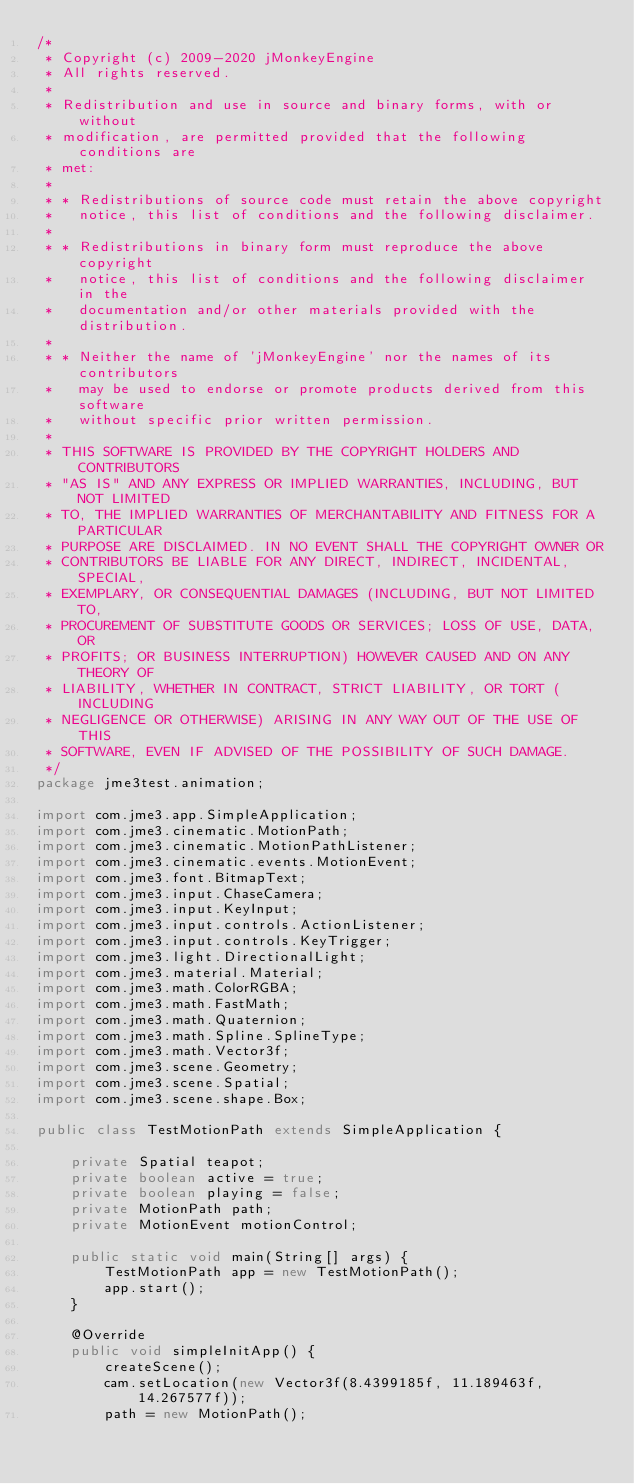Convert code to text. <code><loc_0><loc_0><loc_500><loc_500><_Java_>/*
 * Copyright (c) 2009-2020 jMonkeyEngine
 * All rights reserved.
 *
 * Redistribution and use in source and binary forms, with or without
 * modification, are permitted provided that the following conditions are
 * met:
 *
 * * Redistributions of source code must retain the above copyright
 *   notice, this list of conditions and the following disclaimer.
 *
 * * Redistributions in binary form must reproduce the above copyright
 *   notice, this list of conditions and the following disclaimer in the
 *   documentation and/or other materials provided with the distribution.
 *
 * * Neither the name of 'jMonkeyEngine' nor the names of its contributors
 *   may be used to endorse or promote products derived from this software
 *   without specific prior written permission.
 *
 * THIS SOFTWARE IS PROVIDED BY THE COPYRIGHT HOLDERS AND CONTRIBUTORS
 * "AS IS" AND ANY EXPRESS OR IMPLIED WARRANTIES, INCLUDING, BUT NOT LIMITED
 * TO, THE IMPLIED WARRANTIES OF MERCHANTABILITY AND FITNESS FOR A PARTICULAR
 * PURPOSE ARE DISCLAIMED. IN NO EVENT SHALL THE COPYRIGHT OWNER OR
 * CONTRIBUTORS BE LIABLE FOR ANY DIRECT, INDIRECT, INCIDENTAL, SPECIAL,
 * EXEMPLARY, OR CONSEQUENTIAL DAMAGES (INCLUDING, BUT NOT LIMITED TO,
 * PROCUREMENT OF SUBSTITUTE GOODS OR SERVICES; LOSS OF USE, DATA, OR
 * PROFITS; OR BUSINESS INTERRUPTION) HOWEVER CAUSED AND ON ANY THEORY OF
 * LIABILITY, WHETHER IN CONTRACT, STRICT LIABILITY, OR TORT (INCLUDING
 * NEGLIGENCE OR OTHERWISE) ARISING IN ANY WAY OUT OF THE USE OF THIS
 * SOFTWARE, EVEN IF ADVISED OF THE POSSIBILITY OF SUCH DAMAGE.
 */
package jme3test.animation;

import com.jme3.app.SimpleApplication;
import com.jme3.cinematic.MotionPath;
import com.jme3.cinematic.MotionPathListener;
import com.jme3.cinematic.events.MotionEvent;
import com.jme3.font.BitmapText;
import com.jme3.input.ChaseCamera;
import com.jme3.input.KeyInput;
import com.jme3.input.controls.ActionListener;
import com.jme3.input.controls.KeyTrigger;
import com.jme3.light.DirectionalLight;
import com.jme3.material.Material;
import com.jme3.math.ColorRGBA;
import com.jme3.math.FastMath;
import com.jme3.math.Quaternion;
import com.jme3.math.Spline.SplineType;
import com.jme3.math.Vector3f;
import com.jme3.scene.Geometry;
import com.jme3.scene.Spatial;
import com.jme3.scene.shape.Box;

public class TestMotionPath extends SimpleApplication {

    private Spatial teapot;
    private boolean active = true;
    private boolean playing = false;
    private MotionPath path;
    private MotionEvent motionControl;

    public static void main(String[] args) {
        TestMotionPath app = new TestMotionPath();
        app.start();
    }

    @Override
    public void simpleInitApp() {
        createScene();
        cam.setLocation(new Vector3f(8.4399185f, 11.189463f, 14.267577f));
        path = new MotionPath();</code> 